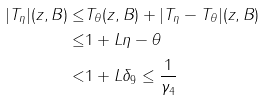Convert formula to latex. <formula><loc_0><loc_0><loc_500><loc_500>| T _ { \eta } | ( z , B ) \leq & T _ { \theta } ( z , B ) + | T _ { \eta } - T _ { \theta } | ( z , B ) \\ \leq & 1 + L \| \eta - \theta \| \\ < & 1 + L \delta _ { 9 } \leq \frac { 1 } { \gamma _ { 4 } }</formula> 